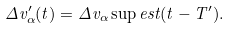<formula> <loc_0><loc_0><loc_500><loc_500>\Delta v ^ { \prime } _ { \alpha } ( t ) = \Delta v _ { \alpha } \sup { e s t } ( t - T ^ { \prime } ) .</formula> 